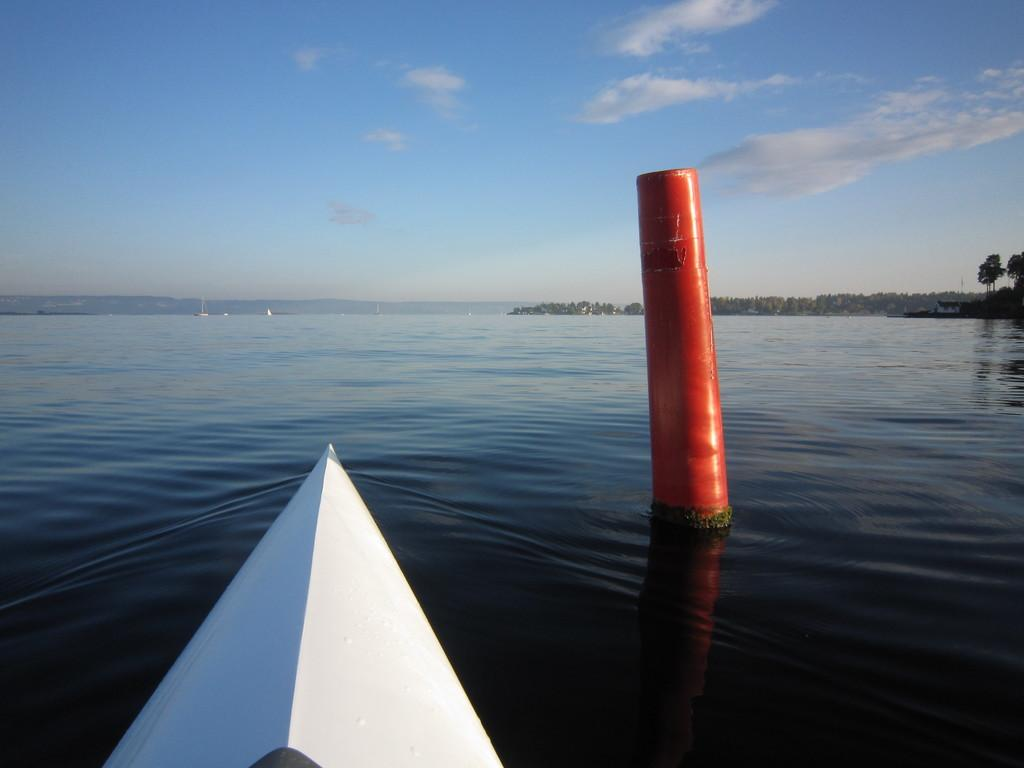What type of body of water is present in the image? There is a lake in the image. What is located in the lake? There is a pole in the lake. Can you see the top of the pole? Yes, the top of the pole is visible. What else can be seen in the image besides the lake and pole? The sky is visible in the image. What is at the bottom of the image? There is an object at the bottom of the image. What type of donkey is working with the laborer in the image? There is no donkey or laborer present in the image. What type of authority figure can be seen in the image? There is no authority figure present in the image. 